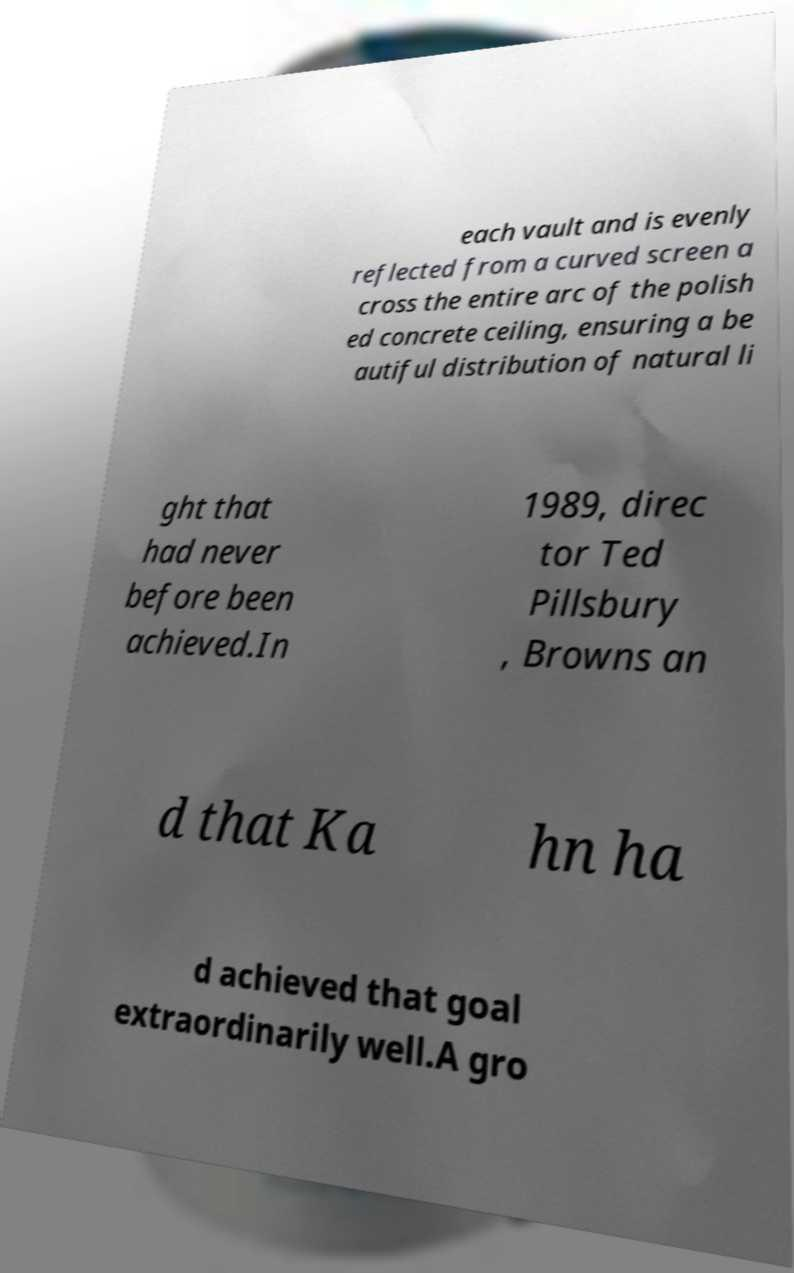Please read and relay the text visible in this image. What does it say? each vault and is evenly reflected from a curved screen a cross the entire arc of the polish ed concrete ceiling, ensuring a be autiful distribution of natural li ght that had never before been achieved.In 1989, direc tor Ted Pillsbury , Browns an d that Ka hn ha d achieved that goal extraordinarily well.A gro 